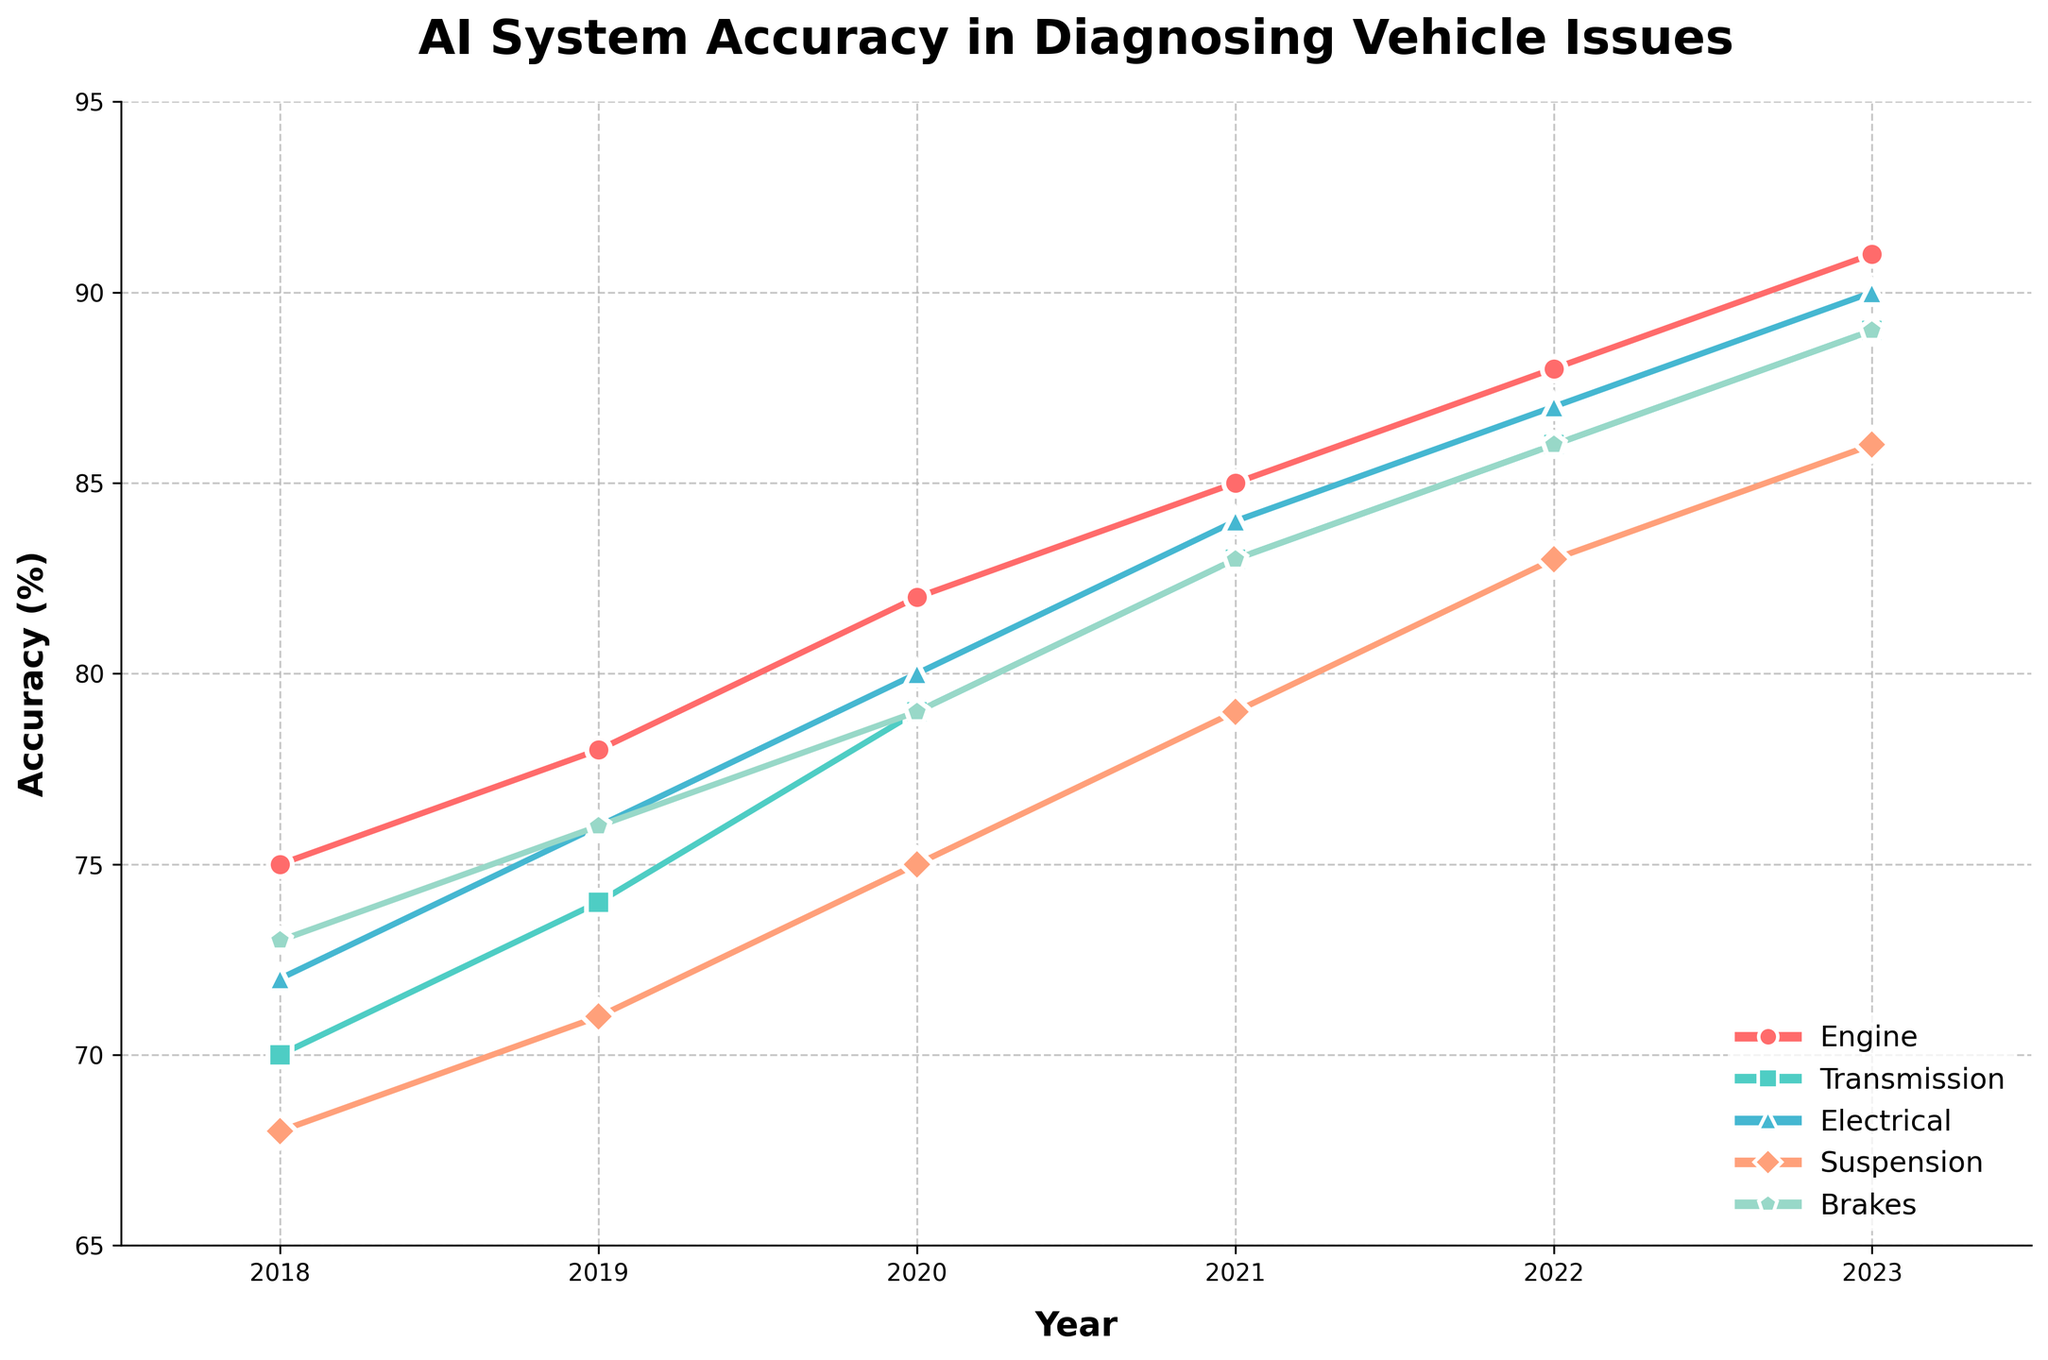What year did the AI system achieve the highest accuracy in diagnosing brake issues? The highest accuracy for diagnosing brake issues is found by looking at the blue color line representing brakes. The peak is in 2023.
Answer: 2023 Which vehicle system showed the most significant improvement in diagnostic accuracy from 2018 to 2023? To determine this, calculate the difference between the 2023 and 2018 accuracies for each system. Engine: 91-75=16, Transmission: 89-70=19, Electrical: 90-72=18, Suspension: 86-68=18, Brakes: 89-73=16. The Transmission system showed the most significant improvement with an increase of 19%.
Answer: Transmission What is the average diagnostic accuracy of AI systems for the electrical system from 2018 to 2023? To find the average, sum all the accuracies for the electrical system and divide by the total number of years. Sum = 72+76+80+84+87+90 = 489. Average = 489/6 = 81.5.
Answer: 81.5 Which system showed the least improvement in accuracy over the given period? Calculate the difference in accuracy over the years for each system: Engine: 91-75=16, Transmission: 89-70=19, Electrical: 90-72=18, Suspension: 86-68=18, Brakes: 89-73=16. The systems with the smallest improvements are Engine and Brakes, both showing an increase of 16%.
Answer: Engine and Brakes How did the accuracy of diagnosing suspension issues change from 2021 to 2022? Check the values in the provided data for 2021 and 2022 for suspension issues. 2021 = 79, 2022 = 83. Calculate the difference, which is 83 - 79 = 4. The accuracy increased by 4%.
Answer: Increased by 4% What is the difference in diagnostic accuracy between the engine and transmission systems in 2023? The 2023 accuracy values for the engine and transmission are 91 and 89, respectively. Calculate the difference, which is 91 - 89 = 2.
Answer: 2 